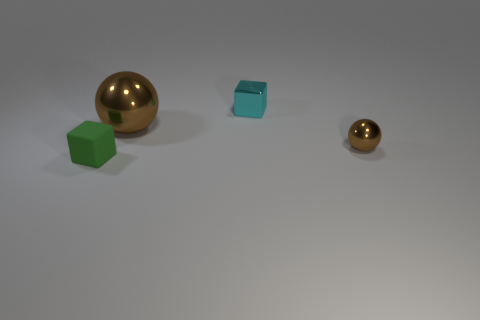Add 2 tiny objects. How many objects exist? 6 Add 2 small shiny objects. How many small shiny objects are left? 4 Add 2 brown shiny spheres. How many brown shiny spheres exist? 4 Subtract 0 gray cylinders. How many objects are left? 4 Subtract 1 balls. How many balls are left? 1 Subtract all blue balls. Subtract all blue blocks. How many balls are left? 2 Subtract all yellow balls. How many purple cubes are left? 0 Subtract all big yellow matte cubes. Subtract all small objects. How many objects are left? 1 